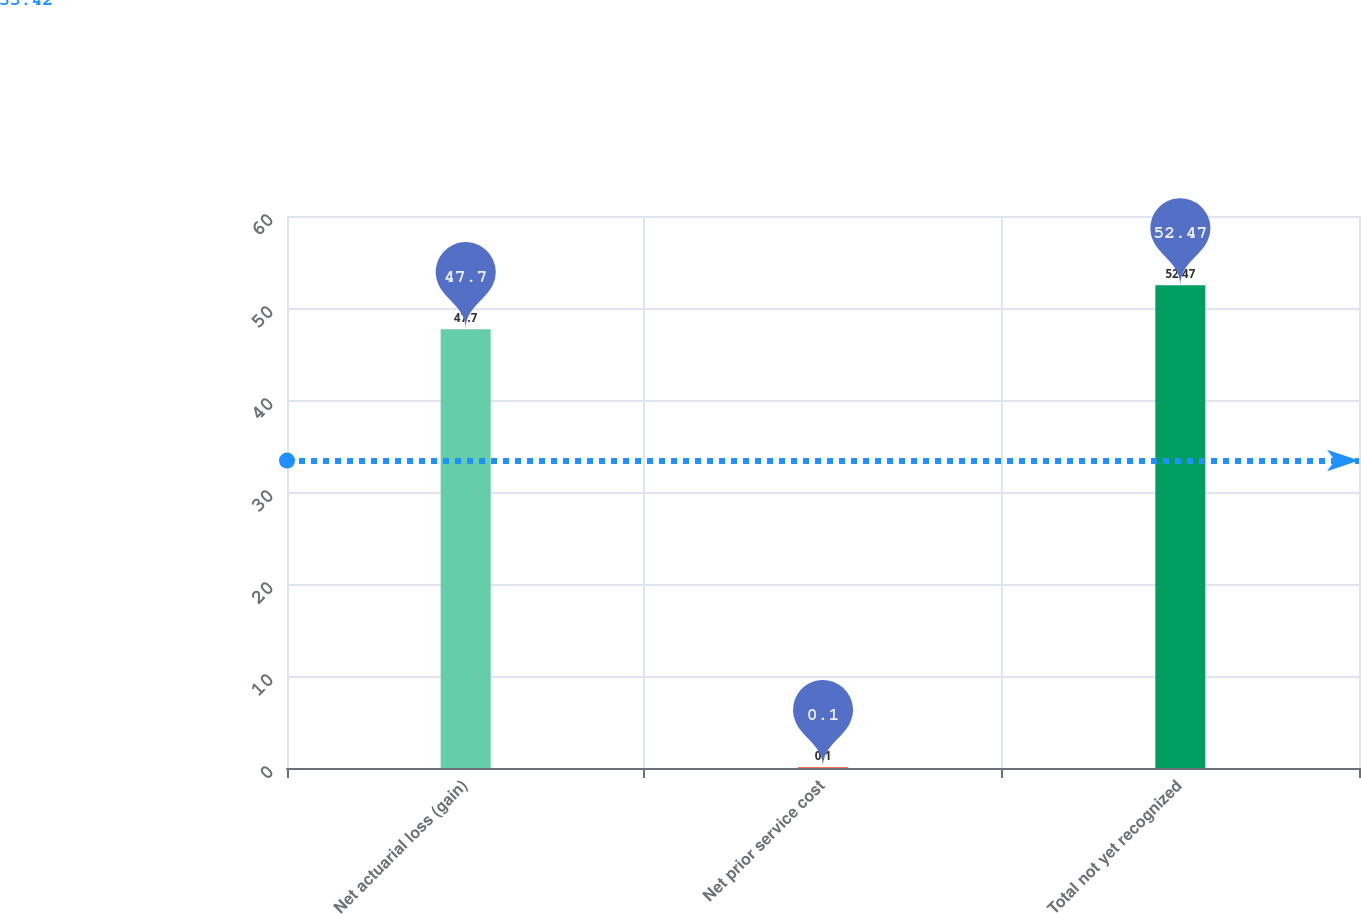Convert chart. <chart><loc_0><loc_0><loc_500><loc_500><bar_chart><fcel>Net actuarial loss (gain)<fcel>Net prior service cost<fcel>Total not yet recognized<nl><fcel>47.7<fcel>0.1<fcel>52.47<nl></chart> 